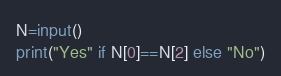<code> <loc_0><loc_0><loc_500><loc_500><_Python_>N=input()
print("Yes" if N[0]==N[2] else "No")</code> 